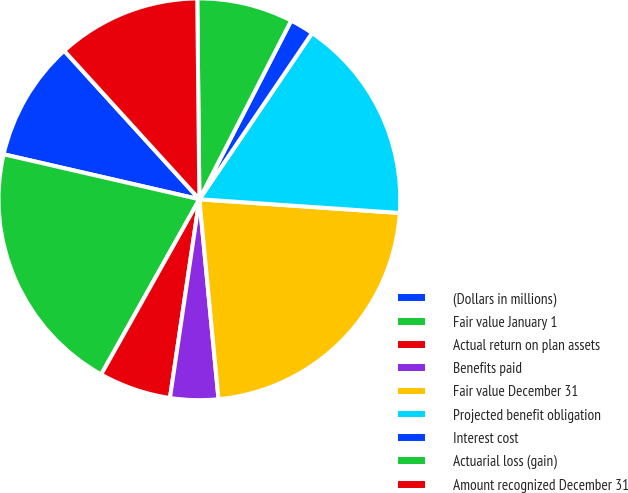<chart> <loc_0><loc_0><loc_500><loc_500><pie_chart><fcel>(Dollars in millions)<fcel>Fair value January 1<fcel>Actual return on plan assets<fcel>Benefits paid<fcel>Fair value December 31<fcel>Projected benefit obligation<fcel>Interest cost<fcel>Actuarial loss (gain)<fcel>Amount recognized December 31<nl><fcel>9.65%<fcel>20.46%<fcel>5.79%<fcel>3.86%<fcel>22.39%<fcel>16.6%<fcel>1.93%<fcel>7.72%<fcel>11.58%<nl></chart> 